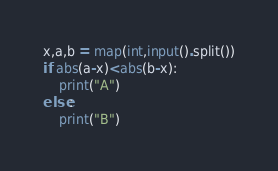<code> <loc_0><loc_0><loc_500><loc_500><_Python_>x,a,b = map(int,input().split())
if abs(a-x)<abs(b-x):
    print("A")
else:
    print("B")
</code> 